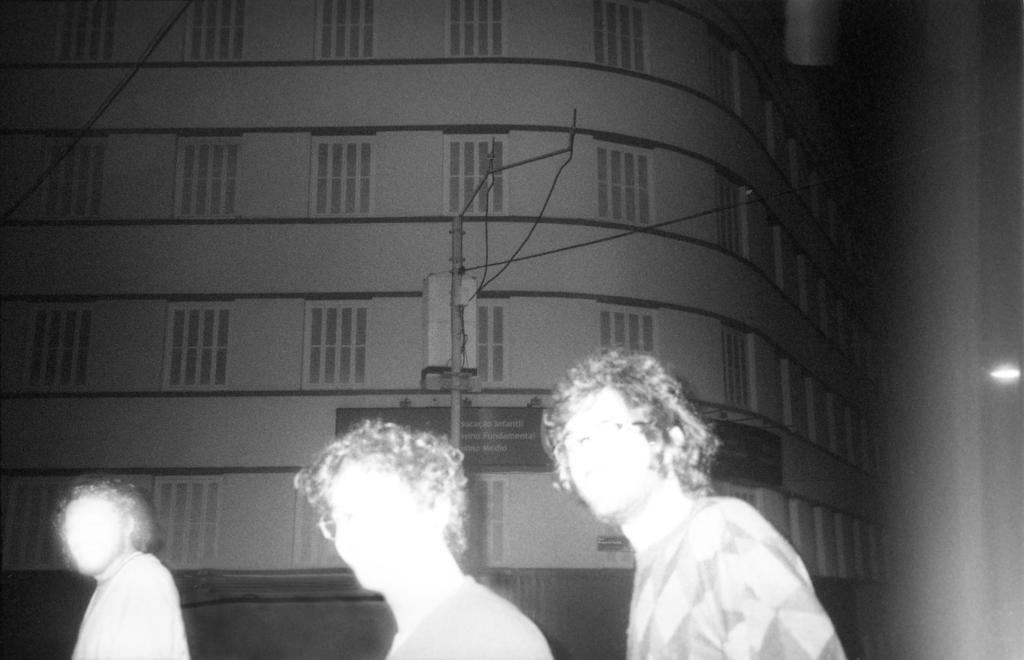Please provide a concise description of this image. This image is taken outdoors. This image is a black and white image. In the background there is a building with walls, windows and there is a board with a text on it. In the middle of the image there is a pole and there are three men. 